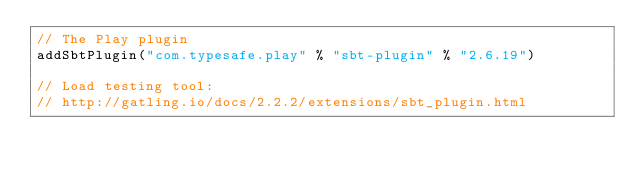Convert code to text. <code><loc_0><loc_0><loc_500><loc_500><_Scala_>// The Play plugin
addSbtPlugin("com.typesafe.play" % "sbt-plugin" % "2.6.19")

// Load testing tool:
// http://gatling.io/docs/2.2.2/extensions/sbt_plugin.html</code> 